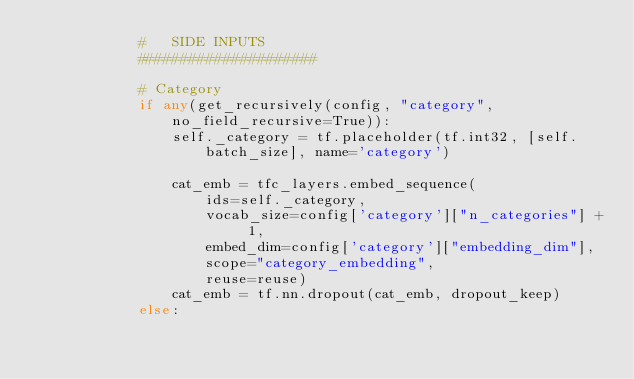<code> <loc_0><loc_0><loc_500><loc_500><_Python_>            #   SIDE INPUTS
            #####################

            # Category
            if any(get_recursively(config, "category", no_field_recursive=True)):
                self._category = tf.placeholder(tf.int32, [self.batch_size], name='category')

                cat_emb = tfc_layers.embed_sequence(
                    ids=self._category,
                    vocab_size=config['category']["n_categories"] + 1,
                    embed_dim=config['category']["embedding_dim"],
                    scope="category_embedding",
                    reuse=reuse)
                cat_emb = tf.nn.dropout(cat_emb, dropout_keep)
            else:</code> 